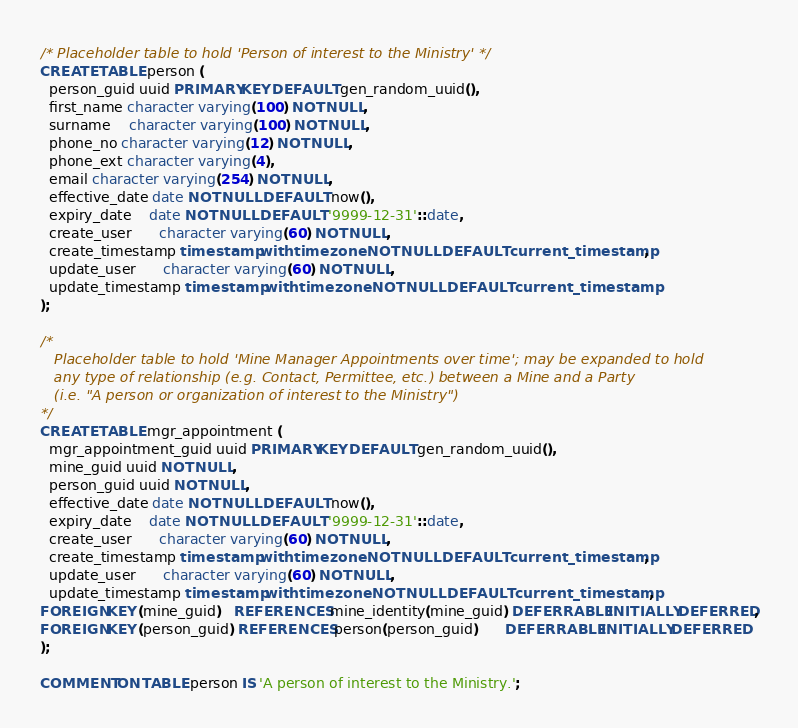<code> <loc_0><loc_0><loc_500><loc_500><_SQL_>/* Placeholder table to hold 'Person of interest to the Ministry' */
CREATE TABLE person (
  person_guid uuid PRIMARY KEY DEFAULT gen_random_uuid(),
  first_name character varying(100) NOT NULL,
  surname    character varying(100) NOT NULL,
  phone_no character varying(12) NOT NULL,
  phone_ext character varying(4),
  email character varying(254) NOT NULL,
  effective_date date NOT NULL DEFAULT now(),
  expiry_date    date NOT NULL DEFAULT '9999-12-31'::date,
  create_user      character varying(60) NOT NULL,
  create_timestamp timestamp with time zone NOT NULL DEFAULT current_timestamp,
  update_user      character varying(60) NOT NULL,
  update_timestamp timestamp with time zone NOT NULL DEFAULT current_timestamp
);

/*
   Placeholder table to hold 'Mine Manager Appointments over time'; may be expanded to hold
   any type of relationship (e.g. Contact, Permittee, etc.) between a Mine and a Party
   (i.e. "A person or organization of interest to the Ministry")
*/
CREATE TABLE mgr_appointment (
  mgr_appointment_guid uuid PRIMARY KEY DEFAULT gen_random_uuid(),
  mine_guid uuid NOT NULL,
  person_guid uuid NOT NULL,
  effective_date date NOT NULL DEFAULT now(),
  expiry_date    date NOT NULL DEFAULT '9999-12-31'::date,
  create_user      character varying(60) NOT NULL,
  create_timestamp timestamp with time zone NOT NULL DEFAULT current_timestamp,
  update_user      character varying(60) NOT NULL,
  update_timestamp timestamp with time zone NOT NULL DEFAULT current_timestamp,
FOREIGN KEY (mine_guid)   REFERENCES mine_identity(mine_guid) DEFERRABLE INITIALLY DEFERRED,
FOREIGN KEY (person_guid) REFERENCES person(person_guid)      DEFERRABLE INITIALLY DEFERRED
);

COMMENT ON TABLE person IS 'A person of interest to the Ministry.';</code> 